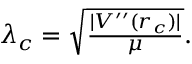<formula> <loc_0><loc_0><loc_500><loc_500>\begin{array} { r } { \lambda _ { c } = \sqrt { \frac { | V ^ { \prime \prime } ( r _ { c } ) | } { \mu } } . } \end{array}</formula> 